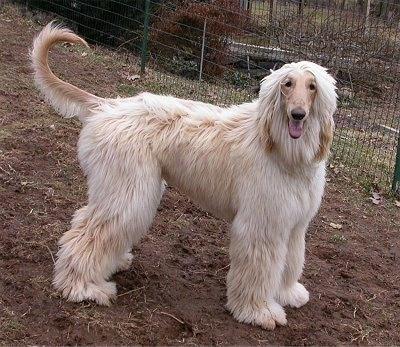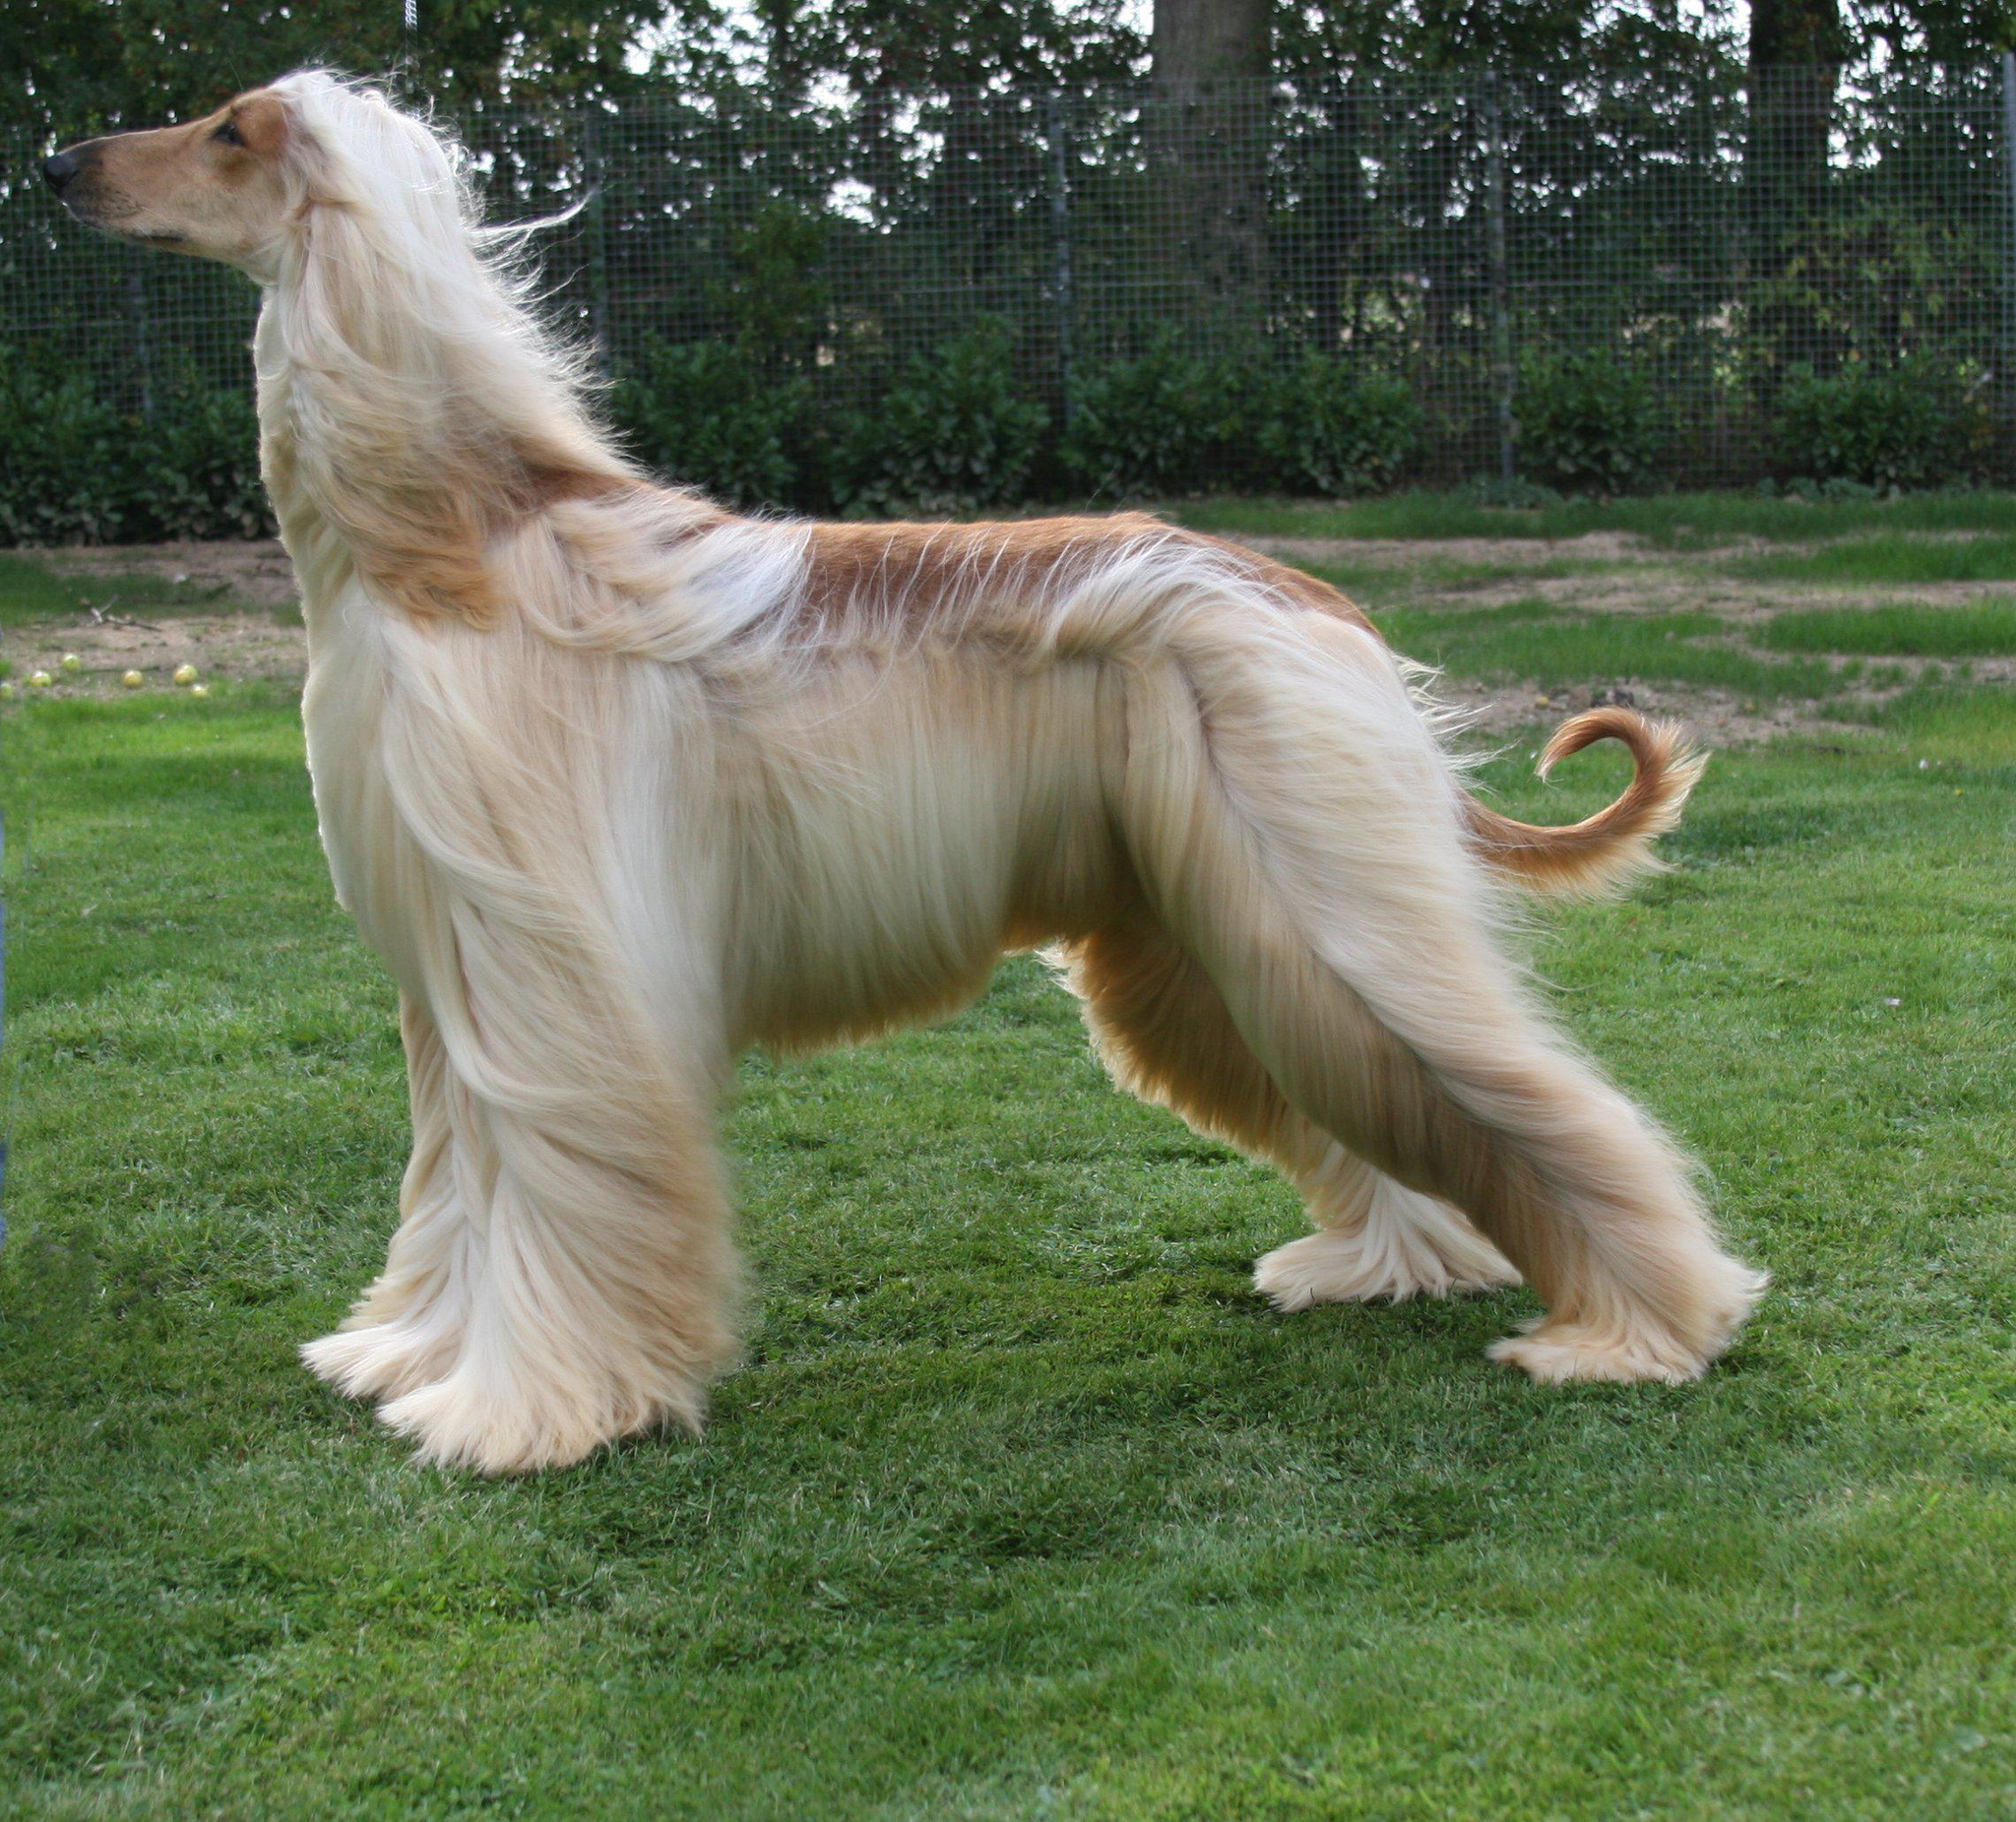The first image is the image on the left, the second image is the image on the right. Analyze the images presented: Is the assertion "An image contains one standing hound with its body and head in profile." valid? Answer yes or no. Yes. The first image is the image on the left, the second image is the image on the right. For the images displayed, is the sentence "There are back and cream colored dogs" factually correct? Answer yes or no. No. 